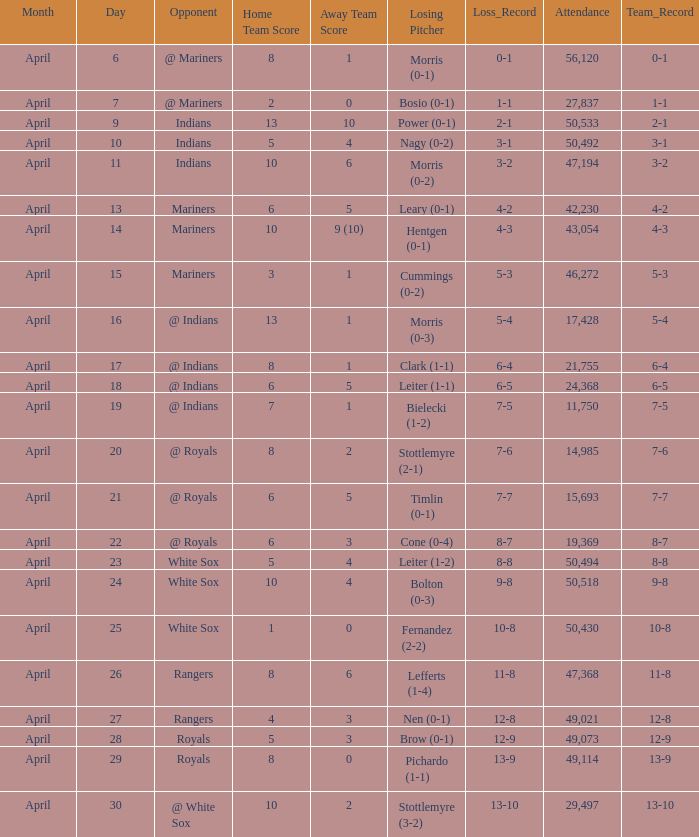What scored is recorded on April 24? 10 - 4. 